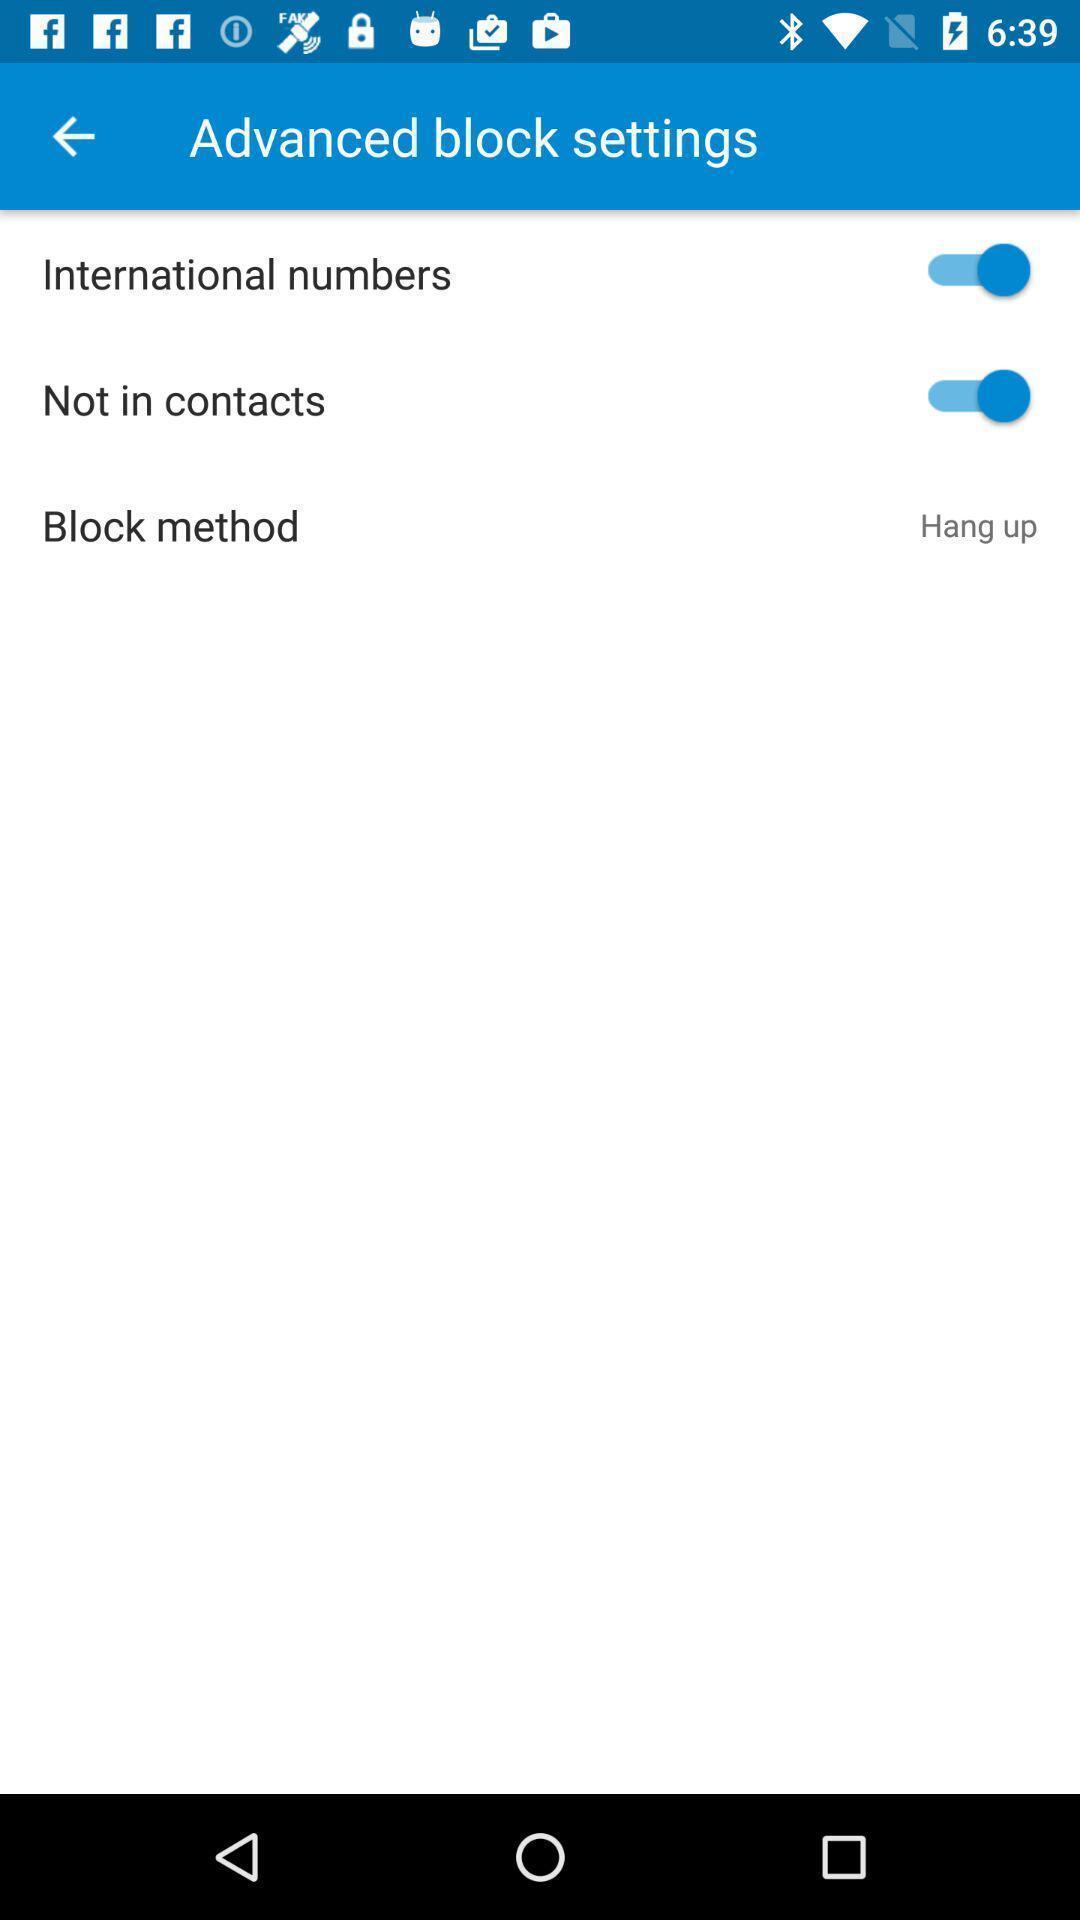Explain the elements present in this screenshot. Settings page of a free calling app. 